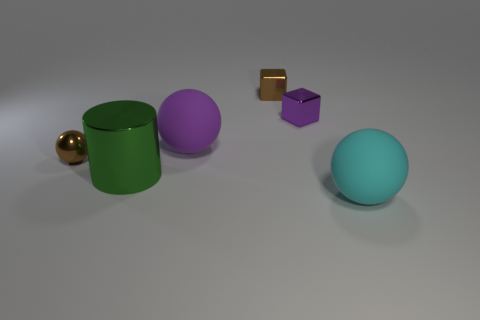Subtract all rubber balls. How many balls are left? 1 Add 3 big brown rubber balls. How many objects exist? 9 Subtract all cubes. How many objects are left? 4 Subtract all big red cylinders. Subtract all big purple balls. How many objects are left? 5 Add 5 tiny brown blocks. How many tiny brown blocks are left? 6 Add 6 big blue things. How many big blue things exist? 6 Subtract 0 red cubes. How many objects are left? 6 